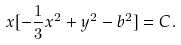<formula> <loc_0><loc_0><loc_500><loc_500>x [ - \frac { 1 } { 3 } x ^ { 2 } + y ^ { 2 } - b ^ { 2 } ] = C .</formula> 